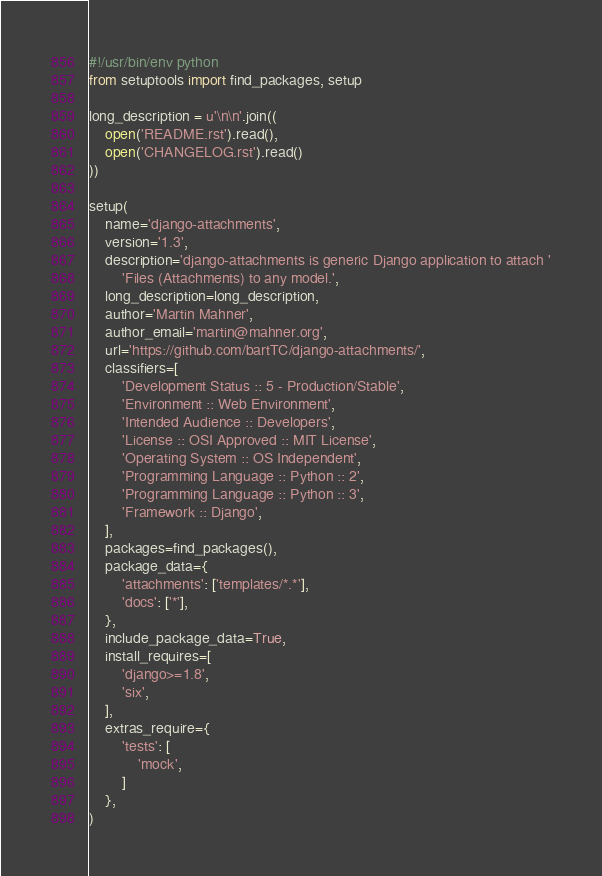<code> <loc_0><loc_0><loc_500><loc_500><_Python_>#!/usr/bin/env python
from setuptools import find_packages, setup

long_description = u'\n\n'.join((
    open('README.rst').read(),
    open('CHANGELOG.rst').read()
))

setup(
    name='django-attachments',
    version='1.3',
    description='django-attachments is generic Django application to attach '
        'Files (Attachments) to any model.',
    long_description=long_description,
    author='Martin Mahner',
    author_email='martin@mahner.org',
    url='https://github.com/bartTC/django-attachments/',
    classifiers=[
        'Development Status :: 5 - Production/Stable',
        'Environment :: Web Environment',
        'Intended Audience :: Developers',
        'License :: OSI Approved :: MIT License',
        'Operating System :: OS Independent',
        'Programming Language :: Python :: 2',
        'Programming Language :: Python :: 3',
        'Framework :: Django',
    ],
    packages=find_packages(),
    package_data={
        'attachments': ['templates/*.*'],
        'docs': ['*'],
    },
    include_package_data=True,
    install_requires=[
        'django>=1.8',
        'six',
    ],
    extras_require={
        'tests': [
            'mock',
        ]
    },
)
</code> 